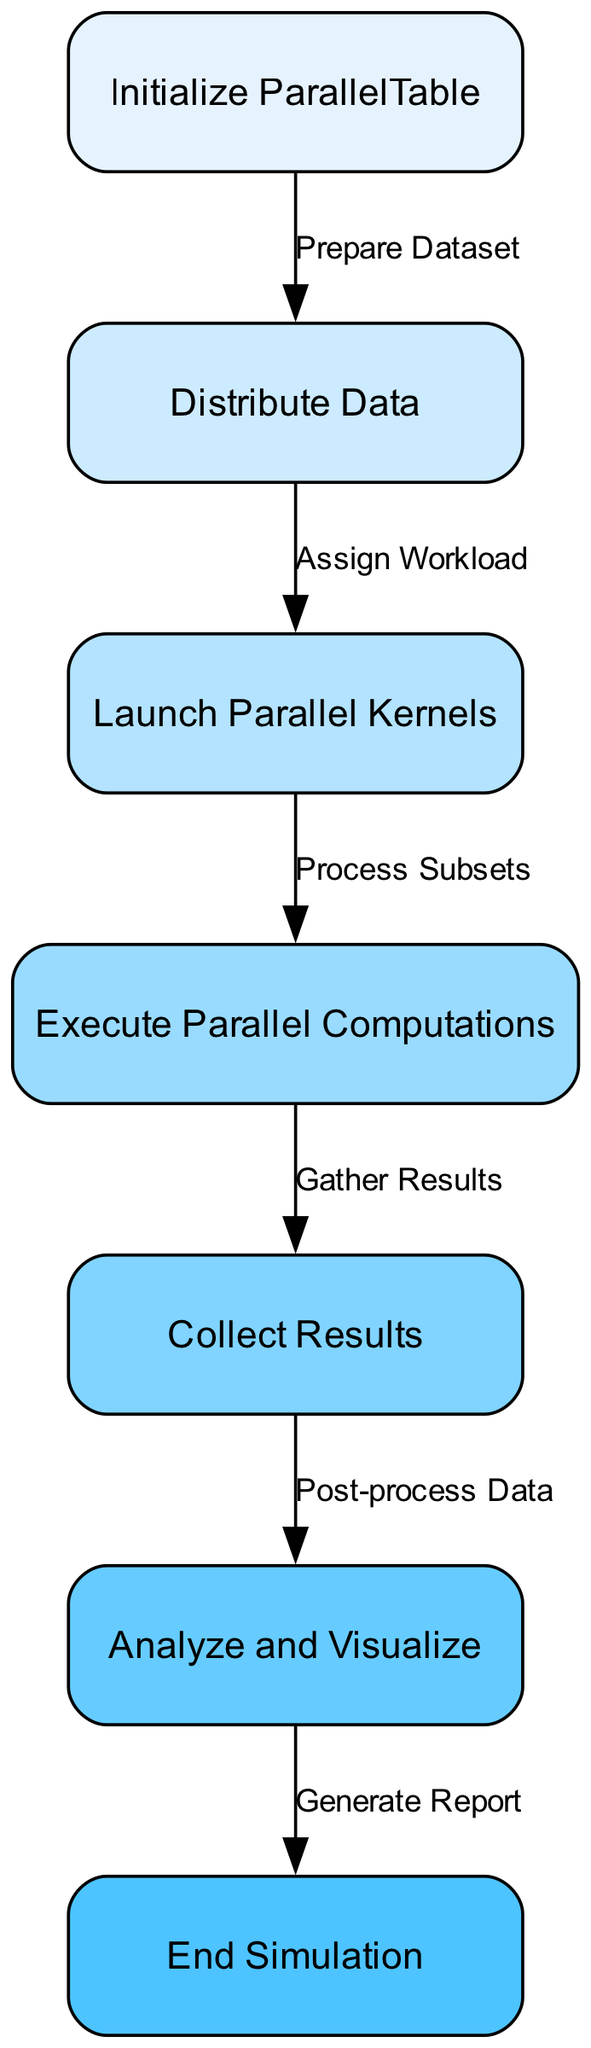What's the first step in the workflow? The first step, as indicated by the "start" node in the diagram, is labeled "Initialize ParallelTable". This node illustrates that the workflow begins with initializing a parallel table, setting the stage for subsequent actions.
Answer: Initialize ParallelTable How many nodes are there in the diagram? By counting the nodes listed in the "nodes" section of the data, we find a total of 7 distinct nodes representing different steps in the workflow. Therefore, the total number of nodes is 7.
Answer: 7 What does the "Collect Results" node follow? According to the diagram structure, the "Collect Results" node follows the "Execute Parallel Computations" node. This indicates that results are gathered after parallel computations are executed.
Answer: Execute Parallel Computations What is the purpose of the "Analyze and Visualize" step? The "Analyze and Visualize" step serves to process the collected data further, allowing for the generation of insights and visual representations from the results. This step represents the analysis phase following result collection.
Answer: Post-process Data Which node directly leads to the "End Simulation"? The node that directly leads to the "End Simulation" node is "Analyze and Visualize". In the workflow, data analysis is crucial before concluding the simulation process, showing sequential dependency.
Answer: Analyze and Visualize How many edges connect the nodes in the diagram? The edges represent the connections and transitions between nodes. Upon examining the "edges" section, we find 6 distinct edges that show the flow from one node to another throughout the workflow.
Answer: 6 What is the label on the edge from "Distribute Data" to "Launch Parallel Kernels"? The edge from "Distribute Data" to "Launch Parallel Kernels" is labeled "Assign Workload". This signifies that during the process of data distribution, workload allocation to the parallel kernels is a significant step.
Answer: Assign Workload What action occurs after "Launch Parallel Kernels"? Following the "Launch Parallel Kernels" action, the next step indicated in the diagram is "Execute Parallel Computations". This shows that the action of launching kernels is immediately followed by computational execution.
Answer: Execute Parallel Computations What is the relationship between "Computations" and "Results"? The relationship indicated is that "Execute Parallel Computations" leads to "Collect Results". This shows that the results of the computations are gathered after the computations have been executed in parallel.
Answer: Gather Results 